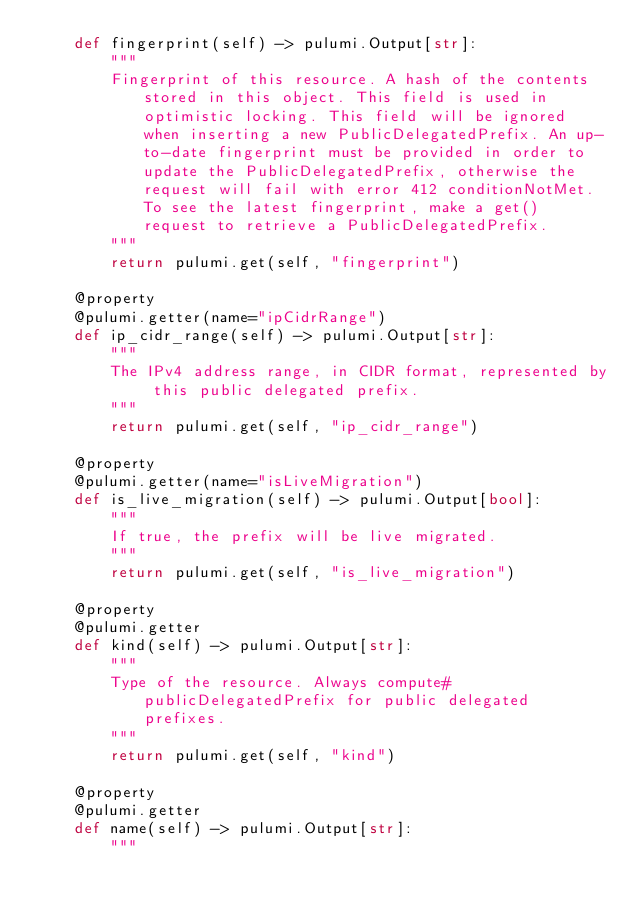Convert code to text. <code><loc_0><loc_0><loc_500><loc_500><_Python_>    def fingerprint(self) -> pulumi.Output[str]:
        """
        Fingerprint of this resource. A hash of the contents stored in this object. This field is used in optimistic locking. This field will be ignored when inserting a new PublicDelegatedPrefix. An up-to-date fingerprint must be provided in order to update the PublicDelegatedPrefix, otherwise the request will fail with error 412 conditionNotMet. To see the latest fingerprint, make a get() request to retrieve a PublicDelegatedPrefix.
        """
        return pulumi.get(self, "fingerprint")

    @property
    @pulumi.getter(name="ipCidrRange")
    def ip_cidr_range(self) -> pulumi.Output[str]:
        """
        The IPv4 address range, in CIDR format, represented by this public delegated prefix.
        """
        return pulumi.get(self, "ip_cidr_range")

    @property
    @pulumi.getter(name="isLiveMigration")
    def is_live_migration(self) -> pulumi.Output[bool]:
        """
        If true, the prefix will be live migrated.
        """
        return pulumi.get(self, "is_live_migration")

    @property
    @pulumi.getter
    def kind(self) -> pulumi.Output[str]:
        """
        Type of the resource. Always compute#publicDelegatedPrefix for public delegated prefixes.
        """
        return pulumi.get(self, "kind")

    @property
    @pulumi.getter
    def name(self) -> pulumi.Output[str]:
        """</code> 